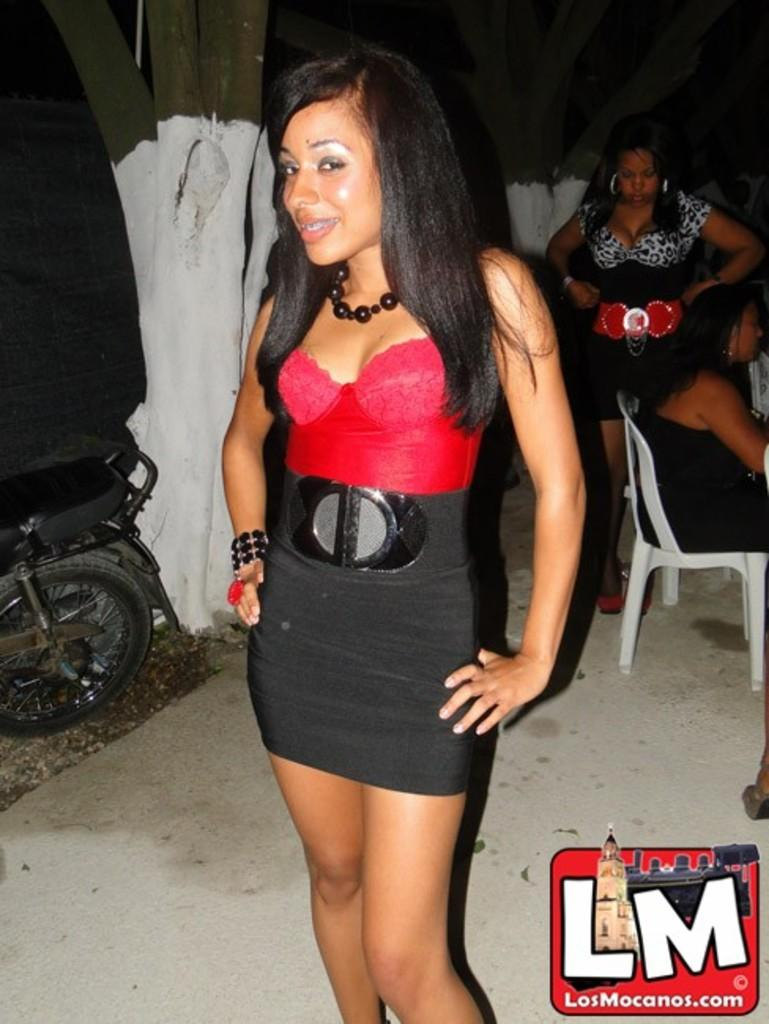How many women are present in the image? There are three women in the image. What are the positions of the women in the image? Two of the women are standing, and one woman is seated on a chair. What other objects can be seen in the image? There is a motorcycle and a tree in the image. What is the profit generated by the motorcycle in the image? There is no information about profit in the image, as it is focused on the women and their positions. 